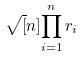Convert formula to latex. <formula><loc_0><loc_0><loc_500><loc_500>\sqrt { [ } n ] { \prod _ { i = 1 } ^ { n } r _ { i } }</formula> 